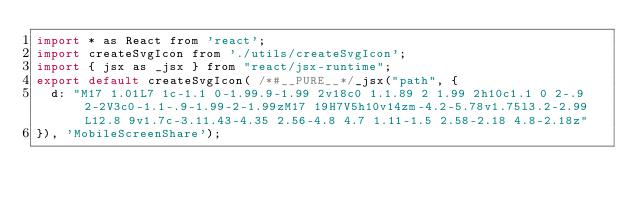Convert code to text. <code><loc_0><loc_0><loc_500><loc_500><_JavaScript_>import * as React from 'react';
import createSvgIcon from './utils/createSvgIcon';
import { jsx as _jsx } from "react/jsx-runtime";
export default createSvgIcon( /*#__PURE__*/_jsx("path", {
  d: "M17 1.01L7 1c-1.1 0-1.99.9-1.99 2v18c0 1.1.89 2 1.99 2h10c1.1 0 2-.9 2-2V3c0-1.1-.9-1.99-2-1.99zM17 19H7V5h10v14zm-4.2-5.78v1.75l3.2-2.99L12.8 9v1.7c-3.11.43-4.35 2.56-4.8 4.7 1.11-1.5 2.58-2.18 4.8-2.18z"
}), 'MobileScreenShare');</code> 